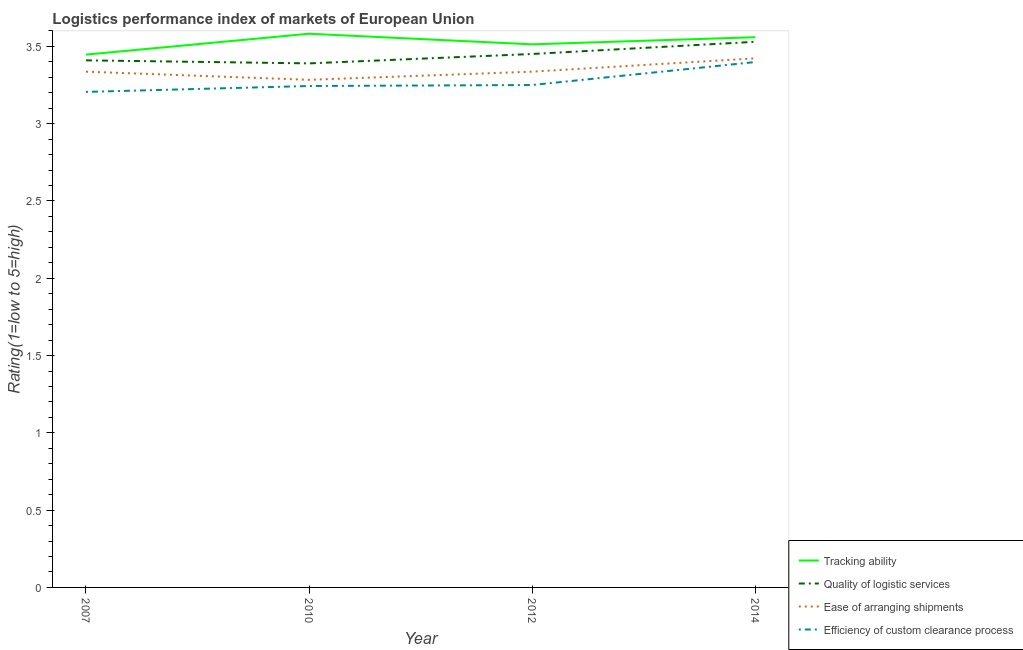How many different coloured lines are there?
Offer a terse response. 4. Is the number of lines equal to the number of legend labels?
Your response must be concise. Yes. What is the lpi rating of ease of arranging shipments in 2012?
Ensure brevity in your answer.  3.34. Across all years, what is the maximum lpi rating of efficiency of custom clearance process?
Your response must be concise. 3.4. Across all years, what is the minimum lpi rating of ease of arranging shipments?
Offer a terse response. 3.28. What is the total lpi rating of ease of arranging shipments in the graph?
Keep it short and to the point. 13.38. What is the difference between the lpi rating of quality of logistic services in 2007 and that in 2010?
Your response must be concise. 0.02. What is the difference between the lpi rating of ease of arranging shipments in 2012 and the lpi rating of efficiency of custom clearance process in 2007?
Offer a very short reply. 0.13. What is the average lpi rating of efficiency of custom clearance process per year?
Ensure brevity in your answer.  3.27. In the year 2010, what is the difference between the lpi rating of efficiency of custom clearance process and lpi rating of ease of arranging shipments?
Provide a short and direct response. -0.04. What is the ratio of the lpi rating of efficiency of custom clearance process in 2007 to that in 2012?
Give a very brief answer. 0.99. Is the difference between the lpi rating of ease of arranging shipments in 2012 and 2014 greater than the difference between the lpi rating of efficiency of custom clearance process in 2012 and 2014?
Offer a terse response. Yes. What is the difference between the highest and the second highest lpi rating of tracking ability?
Provide a short and direct response. 0.02. What is the difference between the highest and the lowest lpi rating of ease of arranging shipments?
Offer a very short reply. 0.14. Is it the case that in every year, the sum of the lpi rating of tracking ability and lpi rating of quality of logistic services is greater than the lpi rating of ease of arranging shipments?
Keep it short and to the point. Yes. Is the lpi rating of ease of arranging shipments strictly less than the lpi rating of tracking ability over the years?
Provide a short and direct response. Yes. How many lines are there?
Your response must be concise. 4. What is the difference between two consecutive major ticks on the Y-axis?
Provide a short and direct response. 0.5. How are the legend labels stacked?
Make the answer very short. Vertical. What is the title of the graph?
Offer a terse response. Logistics performance index of markets of European Union. Does "Finland" appear as one of the legend labels in the graph?
Give a very brief answer. No. What is the label or title of the X-axis?
Provide a short and direct response. Year. What is the label or title of the Y-axis?
Offer a very short reply. Rating(1=low to 5=high). What is the Rating(1=low to 5=high) of Tracking ability in 2007?
Ensure brevity in your answer.  3.45. What is the Rating(1=low to 5=high) in Quality of logistic services in 2007?
Provide a short and direct response. 3.41. What is the Rating(1=low to 5=high) in Ease of arranging shipments in 2007?
Your answer should be compact. 3.34. What is the Rating(1=low to 5=high) in Efficiency of custom clearance process in 2007?
Your answer should be very brief. 3.21. What is the Rating(1=low to 5=high) in Tracking ability in 2010?
Your answer should be compact. 3.58. What is the Rating(1=low to 5=high) in Quality of logistic services in 2010?
Provide a short and direct response. 3.39. What is the Rating(1=low to 5=high) in Ease of arranging shipments in 2010?
Your response must be concise. 3.28. What is the Rating(1=low to 5=high) of Efficiency of custom clearance process in 2010?
Provide a succinct answer. 3.24. What is the Rating(1=low to 5=high) in Tracking ability in 2012?
Offer a very short reply. 3.51. What is the Rating(1=low to 5=high) in Quality of logistic services in 2012?
Provide a short and direct response. 3.45. What is the Rating(1=low to 5=high) in Ease of arranging shipments in 2012?
Your response must be concise. 3.34. What is the Rating(1=low to 5=high) of Efficiency of custom clearance process in 2012?
Your response must be concise. 3.25. What is the Rating(1=low to 5=high) of Tracking ability in 2014?
Your response must be concise. 3.56. What is the Rating(1=low to 5=high) in Quality of logistic services in 2014?
Your answer should be compact. 3.53. What is the Rating(1=low to 5=high) in Ease of arranging shipments in 2014?
Your response must be concise. 3.42. What is the Rating(1=low to 5=high) in Efficiency of custom clearance process in 2014?
Your answer should be very brief. 3.4. Across all years, what is the maximum Rating(1=low to 5=high) of Tracking ability?
Your answer should be compact. 3.58. Across all years, what is the maximum Rating(1=low to 5=high) in Quality of logistic services?
Make the answer very short. 3.53. Across all years, what is the maximum Rating(1=low to 5=high) of Ease of arranging shipments?
Keep it short and to the point. 3.42. Across all years, what is the maximum Rating(1=low to 5=high) in Efficiency of custom clearance process?
Make the answer very short. 3.4. Across all years, what is the minimum Rating(1=low to 5=high) of Tracking ability?
Ensure brevity in your answer.  3.45. Across all years, what is the minimum Rating(1=low to 5=high) of Quality of logistic services?
Provide a short and direct response. 3.39. Across all years, what is the minimum Rating(1=low to 5=high) in Ease of arranging shipments?
Make the answer very short. 3.28. Across all years, what is the minimum Rating(1=low to 5=high) of Efficiency of custom clearance process?
Your answer should be compact. 3.21. What is the total Rating(1=low to 5=high) in Tracking ability in the graph?
Your answer should be compact. 14.1. What is the total Rating(1=low to 5=high) of Quality of logistic services in the graph?
Offer a terse response. 13.78. What is the total Rating(1=low to 5=high) of Ease of arranging shipments in the graph?
Ensure brevity in your answer.  13.38. What is the total Rating(1=low to 5=high) of Efficiency of custom clearance process in the graph?
Ensure brevity in your answer.  13.1. What is the difference between the Rating(1=low to 5=high) of Tracking ability in 2007 and that in 2010?
Your response must be concise. -0.14. What is the difference between the Rating(1=low to 5=high) of Quality of logistic services in 2007 and that in 2010?
Provide a short and direct response. 0.02. What is the difference between the Rating(1=low to 5=high) in Ease of arranging shipments in 2007 and that in 2010?
Offer a very short reply. 0.05. What is the difference between the Rating(1=low to 5=high) of Efficiency of custom clearance process in 2007 and that in 2010?
Provide a succinct answer. -0.04. What is the difference between the Rating(1=low to 5=high) of Tracking ability in 2007 and that in 2012?
Keep it short and to the point. -0.07. What is the difference between the Rating(1=low to 5=high) of Quality of logistic services in 2007 and that in 2012?
Ensure brevity in your answer.  -0.04. What is the difference between the Rating(1=low to 5=high) in Ease of arranging shipments in 2007 and that in 2012?
Offer a very short reply. -0. What is the difference between the Rating(1=low to 5=high) in Efficiency of custom clearance process in 2007 and that in 2012?
Your answer should be very brief. -0.04. What is the difference between the Rating(1=low to 5=high) in Tracking ability in 2007 and that in 2014?
Give a very brief answer. -0.11. What is the difference between the Rating(1=low to 5=high) in Quality of logistic services in 2007 and that in 2014?
Make the answer very short. -0.12. What is the difference between the Rating(1=low to 5=high) of Ease of arranging shipments in 2007 and that in 2014?
Make the answer very short. -0.09. What is the difference between the Rating(1=low to 5=high) in Efficiency of custom clearance process in 2007 and that in 2014?
Provide a short and direct response. -0.19. What is the difference between the Rating(1=low to 5=high) of Tracking ability in 2010 and that in 2012?
Your response must be concise. 0.07. What is the difference between the Rating(1=low to 5=high) in Quality of logistic services in 2010 and that in 2012?
Provide a short and direct response. -0.06. What is the difference between the Rating(1=low to 5=high) in Ease of arranging shipments in 2010 and that in 2012?
Offer a terse response. -0.05. What is the difference between the Rating(1=low to 5=high) of Efficiency of custom clearance process in 2010 and that in 2012?
Offer a very short reply. -0.01. What is the difference between the Rating(1=low to 5=high) in Tracking ability in 2010 and that in 2014?
Provide a short and direct response. 0.02. What is the difference between the Rating(1=low to 5=high) in Quality of logistic services in 2010 and that in 2014?
Give a very brief answer. -0.14. What is the difference between the Rating(1=low to 5=high) of Ease of arranging shipments in 2010 and that in 2014?
Your answer should be compact. -0.14. What is the difference between the Rating(1=low to 5=high) of Efficiency of custom clearance process in 2010 and that in 2014?
Your answer should be compact. -0.16. What is the difference between the Rating(1=low to 5=high) of Tracking ability in 2012 and that in 2014?
Keep it short and to the point. -0.05. What is the difference between the Rating(1=low to 5=high) in Quality of logistic services in 2012 and that in 2014?
Give a very brief answer. -0.08. What is the difference between the Rating(1=low to 5=high) of Ease of arranging shipments in 2012 and that in 2014?
Offer a very short reply. -0.09. What is the difference between the Rating(1=low to 5=high) of Efficiency of custom clearance process in 2012 and that in 2014?
Give a very brief answer. -0.15. What is the difference between the Rating(1=low to 5=high) in Tracking ability in 2007 and the Rating(1=low to 5=high) in Quality of logistic services in 2010?
Keep it short and to the point. 0.06. What is the difference between the Rating(1=low to 5=high) in Tracking ability in 2007 and the Rating(1=low to 5=high) in Ease of arranging shipments in 2010?
Provide a succinct answer. 0.16. What is the difference between the Rating(1=low to 5=high) of Tracking ability in 2007 and the Rating(1=low to 5=high) of Efficiency of custom clearance process in 2010?
Ensure brevity in your answer.  0.2. What is the difference between the Rating(1=low to 5=high) in Quality of logistic services in 2007 and the Rating(1=low to 5=high) in Ease of arranging shipments in 2010?
Keep it short and to the point. 0.13. What is the difference between the Rating(1=low to 5=high) in Quality of logistic services in 2007 and the Rating(1=low to 5=high) in Efficiency of custom clearance process in 2010?
Keep it short and to the point. 0.17. What is the difference between the Rating(1=low to 5=high) in Ease of arranging shipments in 2007 and the Rating(1=low to 5=high) in Efficiency of custom clearance process in 2010?
Provide a succinct answer. 0.09. What is the difference between the Rating(1=low to 5=high) in Tracking ability in 2007 and the Rating(1=low to 5=high) in Quality of logistic services in 2012?
Make the answer very short. -0. What is the difference between the Rating(1=low to 5=high) in Tracking ability in 2007 and the Rating(1=low to 5=high) in Ease of arranging shipments in 2012?
Offer a very short reply. 0.11. What is the difference between the Rating(1=low to 5=high) of Tracking ability in 2007 and the Rating(1=low to 5=high) of Efficiency of custom clearance process in 2012?
Give a very brief answer. 0.2. What is the difference between the Rating(1=low to 5=high) in Quality of logistic services in 2007 and the Rating(1=low to 5=high) in Ease of arranging shipments in 2012?
Make the answer very short. 0.07. What is the difference between the Rating(1=low to 5=high) in Quality of logistic services in 2007 and the Rating(1=low to 5=high) in Efficiency of custom clearance process in 2012?
Your response must be concise. 0.16. What is the difference between the Rating(1=low to 5=high) in Ease of arranging shipments in 2007 and the Rating(1=low to 5=high) in Efficiency of custom clearance process in 2012?
Offer a very short reply. 0.09. What is the difference between the Rating(1=low to 5=high) of Tracking ability in 2007 and the Rating(1=low to 5=high) of Quality of logistic services in 2014?
Make the answer very short. -0.08. What is the difference between the Rating(1=low to 5=high) of Tracking ability in 2007 and the Rating(1=low to 5=high) of Ease of arranging shipments in 2014?
Offer a terse response. 0.02. What is the difference between the Rating(1=low to 5=high) of Tracking ability in 2007 and the Rating(1=low to 5=high) of Efficiency of custom clearance process in 2014?
Offer a terse response. 0.05. What is the difference between the Rating(1=low to 5=high) of Quality of logistic services in 2007 and the Rating(1=low to 5=high) of Ease of arranging shipments in 2014?
Provide a succinct answer. -0.01. What is the difference between the Rating(1=low to 5=high) of Quality of logistic services in 2007 and the Rating(1=low to 5=high) of Efficiency of custom clearance process in 2014?
Ensure brevity in your answer.  0.01. What is the difference between the Rating(1=low to 5=high) in Ease of arranging shipments in 2007 and the Rating(1=low to 5=high) in Efficiency of custom clearance process in 2014?
Your response must be concise. -0.06. What is the difference between the Rating(1=low to 5=high) in Tracking ability in 2010 and the Rating(1=low to 5=high) in Quality of logistic services in 2012?
Your response must be concise. 0.13. What is the difference between the Rating(1=low to 5=high) of Tracking ability in 2010 and the Rating(1=low to 5=high) of Ease of arranging shipments in 2012?
Provide a short and direct response. 0.25. What is the difference between the Rating(1=low to 5=high) of Tracking ability in 2010 and the Rating(1=low to 5=high) of Efficiency of custom clearance process in 2012?
Give a very brief answer. 0.33. What is the difference between the Rating(1=low to 5=high) in Quality of logistic services in 2010 and the Rating(1=low to 5=high) in Ease of arranging shipments in 2012?
Your answer should be compact. 0.05. What is the difference between the Rating(1=low to 5=high) in Quality of logistic services in 2010 and the Rating(1=low to 5=high) in Efficiency of custom clearance process in 2012?
Provide a short and direct response. 0.14. What is the difference between the Rating(1=low to 5=high) in Ease of arranging shipments in 2010 and the Rating(1=low to 5=high) in Efficiency of custom clearance process in 2012?
Your answer should be very brief. 0.03. What is the difference between the Rating(1=low to 5=high) in Tracking ability in 2010 and the Rating(1=low to 5=high) in Quality of logistic services in 2014?
Make the answer very short. 0.05. What is the difference between the Rating(1=low to 5=high) of Tracking ability in 2010 and the Rating(1=low to 5=high) of Ease of arranging shipments in 2014?
Your answer should be compact. 0.16. What is the difference between the Rating(1=low to 5=high) of Tracking ability in 2010 and the Rating(1=low to 5=high) of Efficiency of custom clearance process in 2014?
Make the answer very short. 0.18. What is the difference between the Rating(1=low to 5=high) in Quality of logistic services in 2010 and the Rating(1=low to 5=high) in Ease of arranging shipments in 2014?
Ensure brevity in your answer.  -0.03. What is the difference between the Rating(1=low to 5=high) of Quality of logistic services in 2010 and the Rating(1=low to 5=high) of Efficiency of custom clearance process in 2014?
Make the answer very short. -0.01. What is the difference between the Rating(1=low to 5=high) of Ease of arranging shipments in 2010 and the Rating(1=low to 5=high) of Efficiency of custom clearance process in 2014?
Provide a succinct answer. -0.12. What is the difference between the Rating(1=low to 5=high) in Tracking ability in 2012 and the Rating(1=low to 5=high) in Quality of logistic services in 2014?
Offer a very short reply. -0.02. What is the difference between the Rating(1=low to 5=high) in Tracking ability in 2012 and the Rating(1=low to 5=high) in Ease of arranging shipments in 2014?
Keep it short and to the point. 0.09. What is the difference between the Rating(1=low to 5=high) in Tracking ability in 2012 and the Rating(1=low to 5=high) in Efficiency of custom clearance process in 2014?
Keep it short and to the point. 0.11. What is the difference between the Rating(1=low to 5=high) of Quality of logistic services in 2012 and the Rating(1=low to 5=high) of Ease of arranging shipments in 2014?
Keep it short and to the point. 0.03. What is the difference between the Rating(1=low to 5=high) of Quality of logistic services in 2012 and the Rating(1=low to 5=high) of Efficiency of custom clearance process in 2014?
Your answer should be very brief. 0.05. What is the difference between the Rating(1=low to 5=high) of Ease of arranging shipments in 2012 and the Rating(1=low to 5=high) of Efficiency of custom clearance process in 2014?
Ensure brevity in your answer.  -0.06. What is the average Rating(1=low to 5=high) in Tracking ability per year?
Provide a succinct answer. 3.53. What is the average Rating(1=low to 5=high) in Quality of logistic services per year?
Offer a terse response. 3.45. What is the average Rating(1=low to 5=high) of Ease of arranging shipments per year?
Offer a very short reply. 3.35. What is the average Rating(1=low to 5=high) of Efficiency of custom clearance process per year?
Make the answer very short. 3.27. In the year 2007, what is the difference between the Rating(1=low to 5=high) in Tracking ability and Rating(1=low to 5=high) in Quality of logistic services?
Your response must be concise. 0.04. In the year 2007, what is the difference between the Rating(1=low to 5=high) of Tracking ability and Rating(1=low to 5=high) of Ease of arranging shipments?
Give a very brief answer. 0.11. In the year 2007, what is the difference between the Rating(1=low to 5=high) in Tracking ability and Rating(1=low to 5=high) in Efficiency of custom clearance process?
Your answer should be compact. 0.24. In the year 2007, what is the difference between the Rating(1=low to 5=high) of Quality of logistic services and Rating(1=low to 5=high) of Ease of arranging shipments?
Offer a very short reply. 0.07. In the year 2007, what is the difference between the Rating(1=low to 5=high) of Quality of logistic services and Rating(1=low to 5=high) of Efficiency of custom clearance process?
Ensure brevity in your answer.  0.2. In the year 2007, what is the difference between the Rating(1=low to 5=high) of Ease of arranging shipments and Rating(1=low to 5=high) of Efficiency of custom clearance process?
Your response must be concise. 0.13. In the year 2010, what is the difference between the Rating(1=low to 5=high) of Tracking ability and Rating(1=low to 5=high) of Quality of logistic services?
Give a very brief answer. 0.19. In the year 2010, what is the difference between the Rating(1=low to 5=high) in Tracking ability and Rating(1=low to 5=high) in Ease of arranging shipments?
Give a very brief answer. 0.3. In the year 2010, what is the difference between the Rating(1=low to 5=high) of Tracking ability and Rating(1=low to 5=high) of Efficiency of custom clearance process?
Offer a terse response. 0.34. In the year 2010, what is the difference between the Rating(1=low to 5=high) in Quality of logistic services and Rating(1=low to 5=high) in Ease of arranging shipments?
Offer a very short reply. 0.11. In the year 2010, what is the difference between the Rating(1=low to 5=high) of Quality of logistic services and Rating(1=low to 5=high) of Efficiency of custom clearance process?
Ensure brevity in your answer.  0.15. In the year 2012, what is the difference between the Rating(1=low to 5=high) in Tracking ability and Rating(1=low to 5=high) in Quality of logistic services?
Offer a terse response. 0.06. In the year 2012, what is the difference between the Rating(1=low to 5=high) in Tracking ability and Rating(1=low to 5=high) in Ease of arranging shipments?
Provide a succinct answer. 0.18. In the year 2012, what is the difference between the Rating(1=low to 5=high) of Tracking ability and Rating(1=low to 5=high) of Efficiency of custom clearance process?
Keep it short and to the point. 0.26. In the year 2012, what is the difference between the Rating(1=low to 5=high) of Quality of logistic services and Rating(1=low to 5=high) of Ease of arranging shipments?
Provide a short and direct response. 0.11. In the year 2012, what is the difference between the Rating(1=low to 5=high) of Quality of logistic services and Rating(1=low to 5=high) of Efficiency of custom clearance process?
Offer a terse response. 0.2. In the year 2012, what is the difference between the Rating(1=low to 5=high) of Ease of arranging shipments and Rating(1=low to 5=high) of Efficiency of custom clearance process?
Your answer should be compact. 0.09. In the year 2014, what is the difference between the Rating(1=low to 5=high) of Tracking ability and Rating(1=low to 5=high) of Quality of logistic services?
Keep it short and to the point. 0.03. In the year 2014, what is the difference between the Rating(1=low to 5=high) of Tracking ability and Rating(1=low to 5=high) of Ease of arranging shipments?
Offer a very short reply. 0.14. In the year 2014, what is the difference between the Rating(1=low to 5=high) in Tracking ability and Rating(1=low to 5=high) in Efficiency of custom clearance process?
Provide a short and direct response. 0.16. In the year 2014, what is the difference between the Rating(1=low to 5=high) of Quality of logistic services and Rating(1=low to 5=high) of Ease of arranging shipments?
Give a very brief answer. 0.11. In the year 2014, what is the difference between the Rating(1=low to 5=high) in Quality of logistic services and Rating(1=low to 5=high) in Efficiency of custom clearance process?
Provide a succinct answer. 0.13. In the year 2014, what is the difference between the Rating(1=low to 5=high) of Ease of arranging shipments and Rating(1=low to 5=high) of Efficiency of custom clearance process?
Offer a very short reply. 0.02. What is the ratio of the Rating(1=low to 5=high) of Tracking ability in 2007 to that in 2010?
Make the answer very short. 0.96. What is the ratio of the Rating(1=low to 5=high) in Ease of arranging shipments in 2007 to that in 2010?
Make the answer very short. 1.02. What is the ratio of the Rating(1=low to 5=high) in Efficiency of custom clearance process in 2007 to that in 2010?
Make the answer very short. 0.99. What is the ratio of the Rating(1=low to 5=high) in Tracking ability in 2007 to that in 2012?
Your response must be concise. 0.98. What is the ratio of the Rating(1=low to 5=high) in Ease of arranging shipments in 2007 to that in 2012?
Ensure brevity in your answer.  1. What is the ratio of the Rating(1=low to 5=high) in Efficiency of custom clearance process in 2007 to that in 2012?
Provide a succinct answer. 0.99. What is the ratio of the Rating(1=low to 5=high) in Tracking ability in 2007 to that in 2014?
Give a very brief answer. 0.97. What is the ratio of the Rating(1=low to 5=high) in Ease of arranging shipments in 2007 to that in 2014?
Ensure brevity in your answer.  0.97. What is the ratio of the Rating(1=low to 5=high) in Efficiency of custom clearance process in 2007 to that in 2014?
Ensure brevity in your answer.  0.94. What is the ratio of the Rating(1=low to 5=high) in Tracking ability in 2010 to that in 2012?
Make the answer very short. 1.02. What is the ratio of the Rating(1=low to 5=high) in Quality of logistic services in 2010 to that in 2012?
Make the answer very short. 0.98. What is the ratio of the Rating(1=low to 5=high) of Ease of arranging shipments in 2010 to that in 2012?
Provide a succinct answer. 0.98. What is the ratio of the Rating(1=low to 5=high) in Efficiency of custom clearance process in 2010 to that in 2012?
Offer a very short reply. 1. What is the ratio of the Rating(1=low to 5=high) of Quality of logistic services in 2010 to that in 2014?
Offer a very short reply. 0.96. What is the ratio of the Rating(1=low to 5=high) in Ease of arranging shipments in 2010 to that in 2014?
Provide a succinct answer. 0.96. What is the ratio of the Rating(1=low to 5=high) of Efficiency of custom clearance process in 2010 to that in 2014?
Ensure brevity in your answer.  0.95. What is the ratio of the Rating(1=low to 5=high) of Tracking ability in 2012 to that in 2014?
Offer a very short reply. 0.99. What is the ratio of the Rating(1=low to 5=high) of Quality of logistic services in 2012 to that in 2014?
Make the answer very short. 0.98. What is the ratio of the Rating(1=low to 5=high) in Ease of arranging shipments in 2012 to that in 2014?
Make the answer very short. 0.97. What is the ratio of the Rating(1=low to 5=high) in Efficiency of custom clearance process in 2012 to that in 2014?
Your answer should be compact. 0.96. What is the difference between the highest and the second highest Rating(1=low to 5=high) of Tracking ability?
Make the answer very short. 0.02. What is the difference between the highest and the second highest Rating(1=low to 5=high) in Quality of logistic services?
Offer a terse response. 0.08. What is the difference between the highest and the second highest Rating(1=low to 5=high) in Ease of arranging shipments?
Your answer should be compact. 0.09. What is the difference between the highest and the second highest Rating(1=low to 5=high) in Efficiency of custom clearance process?
Ensure brevity in your answer.  0.15. What is the difference between the highest and the lowest Rating(1=low to 5=high) in Tracking ability?
Provide a succinct answer. 0.14. What is the difference between the highest and the lowest Rating(1=low to 5=high) in Quality of logistic services?
Ensure brevity in your answer.  0.14. What is the difference between the highest and the lowest Rating(1=low to 5=high) of Ease of arranging shipments?
Provide a short and direct response. 0.14. What is the difference between the highest and the lowest Rating(1=low to 5=high) in Efficiency of custom clearance process?
Your answer should be compact. 0.19. 